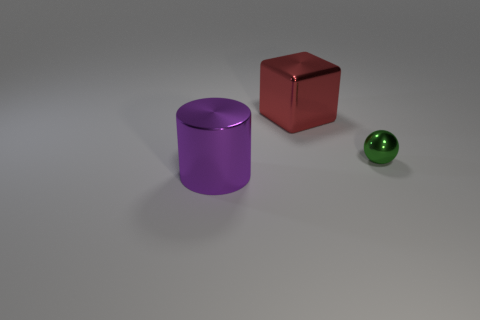What color is the object that is in front of the tiny shiny sphere? The object in front of the tiny shiny sphere is a cylinder with a rich purple color. 